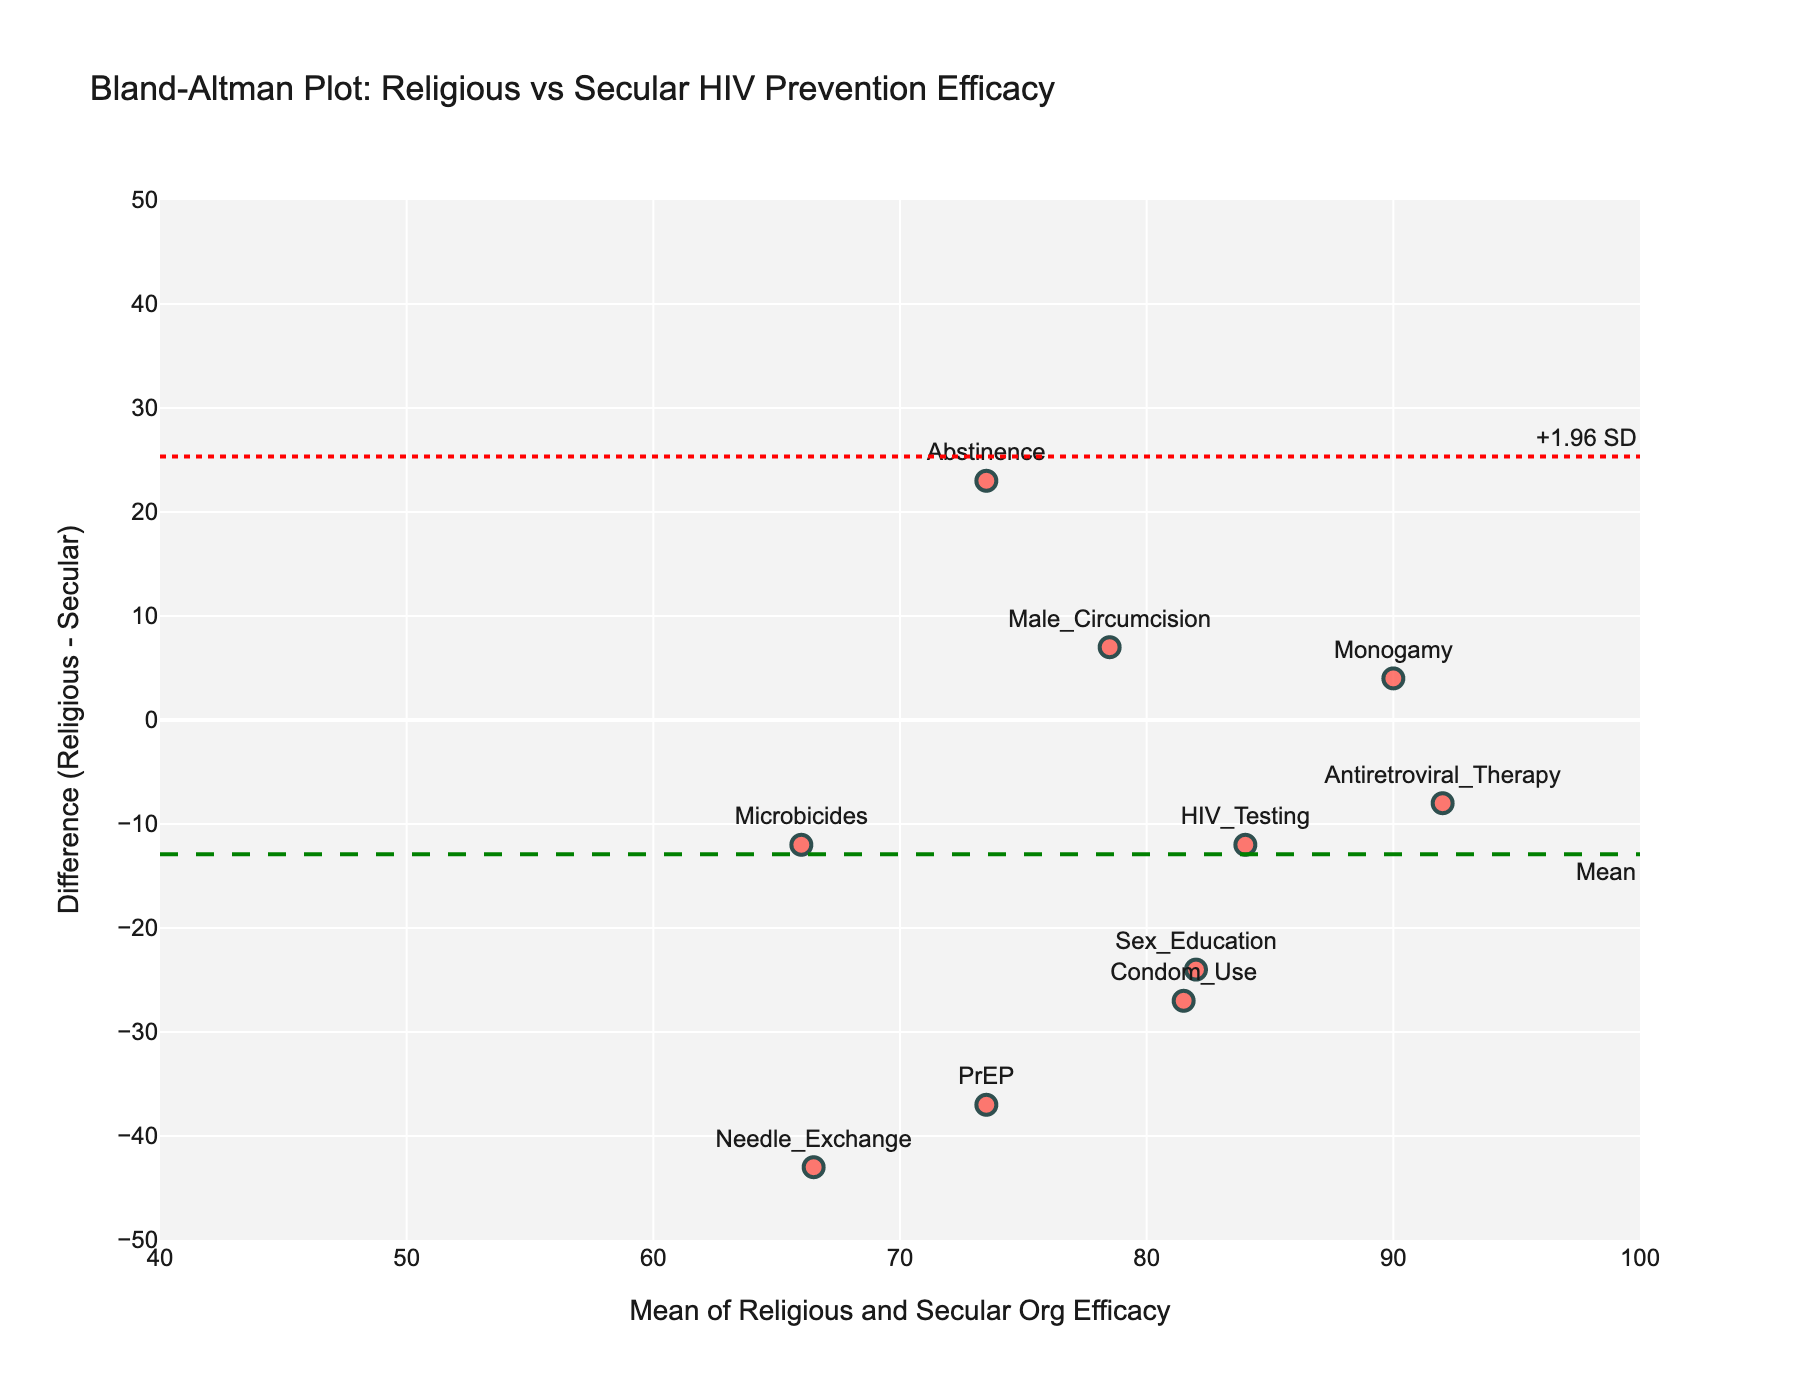What is the title of the plot? The title of the plot is usually written at the top of the figure. In this case, the title is "Bland-Altman Plot: Religious vs Secular HIV Prevention Efficacy".
Answer: Bland-Altman Plot: Religious vs Secular HIV Prevention Efficacy How many data points are shown in the plot? Each method listed in the data corresponds to a data point in the plot. Counting all the methods (from Abstinence to Microbicides) gives 10 data points.
Answer: 10 Which method shows the smallest difference in efficacy between religious and secular organizations? To identify the method with the smallest difference, look for the point closest to the horizontal axis (y=0). "Monogamy" is the closest to y=0 with a difference of 4.
Answer: Monogamy What is the mean difference between the religious and secular organizations' efficacy for all methods? The mean difference is indicated by the green dashed line annotated with "Mean". It intersects the y-axis around -10.
Answer: -10 Which method has the highest efficacy difference favoring secular organizations? The method with the most negative difference is "PrEP," which has a large negative difference as it is plotted far below the horizontal axis.
Answer: PrEP What are the upper and lower limits of agreement? The limits of agreement are indicated by the red dotted lines annotated with "+1.96 SD" and "-1.96 SD". They intersect the y-axis around 31 and -51 respectively.
Answer: 31 and -51 What is the mean efficacy reported by both organizations for Male Circumcision? The x-axis shows the mean efficacy of both organizations. Find the data point for "Male Circumcision," and its x-coordinate gives the mean efficacy. It's around 78.5.
Answer: 78.5 How many methods do religious organizations report as more effective than secular organizations? Count the points that are above the horizontal axis (y=0), as these points represent methods where religious organizations report higher efficacy. There are 4 such points: Abstinence, Monogamy, Male Circumcision, and Antiretroviral Therapy.
Answer: 4 What is the range of efficacy differences reported by the religious and secular organizations? The range is the difference between the maximum and minimum difference values on the y-axis. The maximum positive difference is around 23, and the minimum negative difference is about -41. The range is thus 23 - (-41) = 64.
Answer: 64 For which method is the mean of the reported efficacy values the highest? Look for the data point furthest to the right on the x-axis. "Antiretroviral Therapy" has the highest x-coordinate for mean efficacy.
Answer: Antiretroviral Therapy 